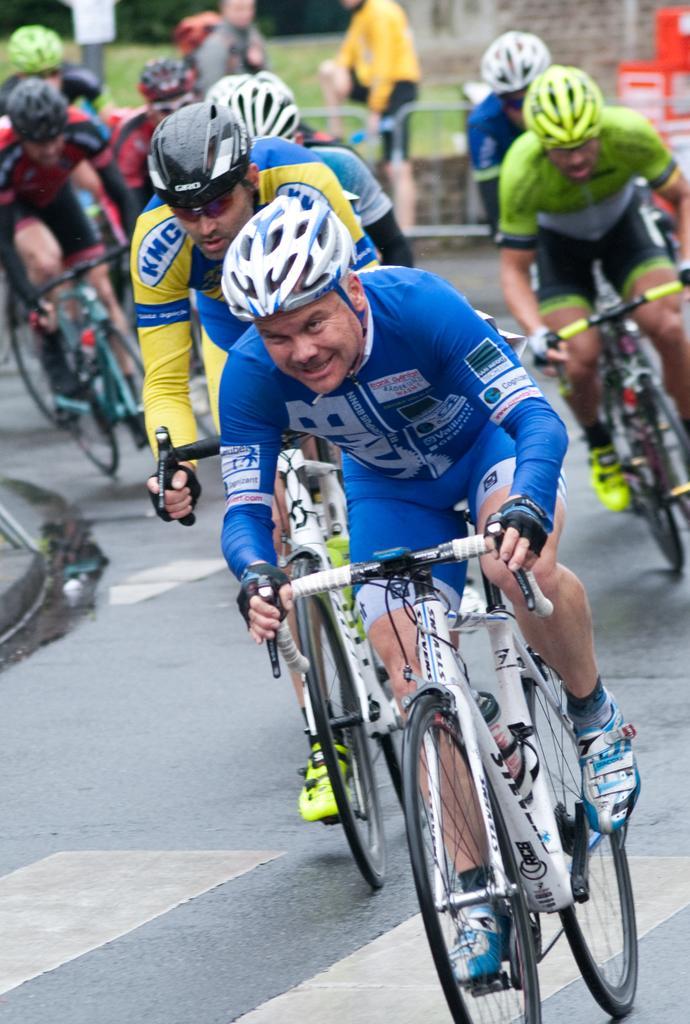Can you describe this image briefly? In the picture we can see a many people are riding a bicycles wearing a helmets and shoes. 